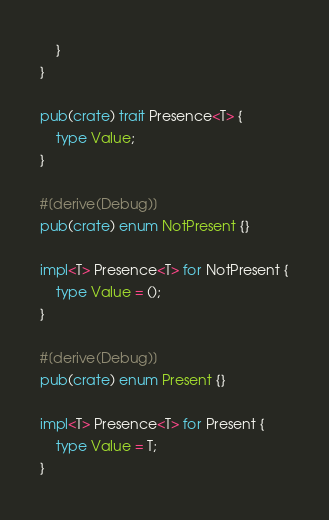<code> <loc_0><loc_0><loc_500><loc_500><_Rust_>    }
}

pub(crate) trait Presence<T> {
    type Value;
}

#[derive(Debug)]
pub(crate) enum NotPresent {}

impl<T> Presence<T> for NotPresent {
    type Value = ();
}

#[derive(Debug)]
pub(crate) enum Present {}

impl<T> Presence<T> for Present {
    type Value = T;
}
</code> 